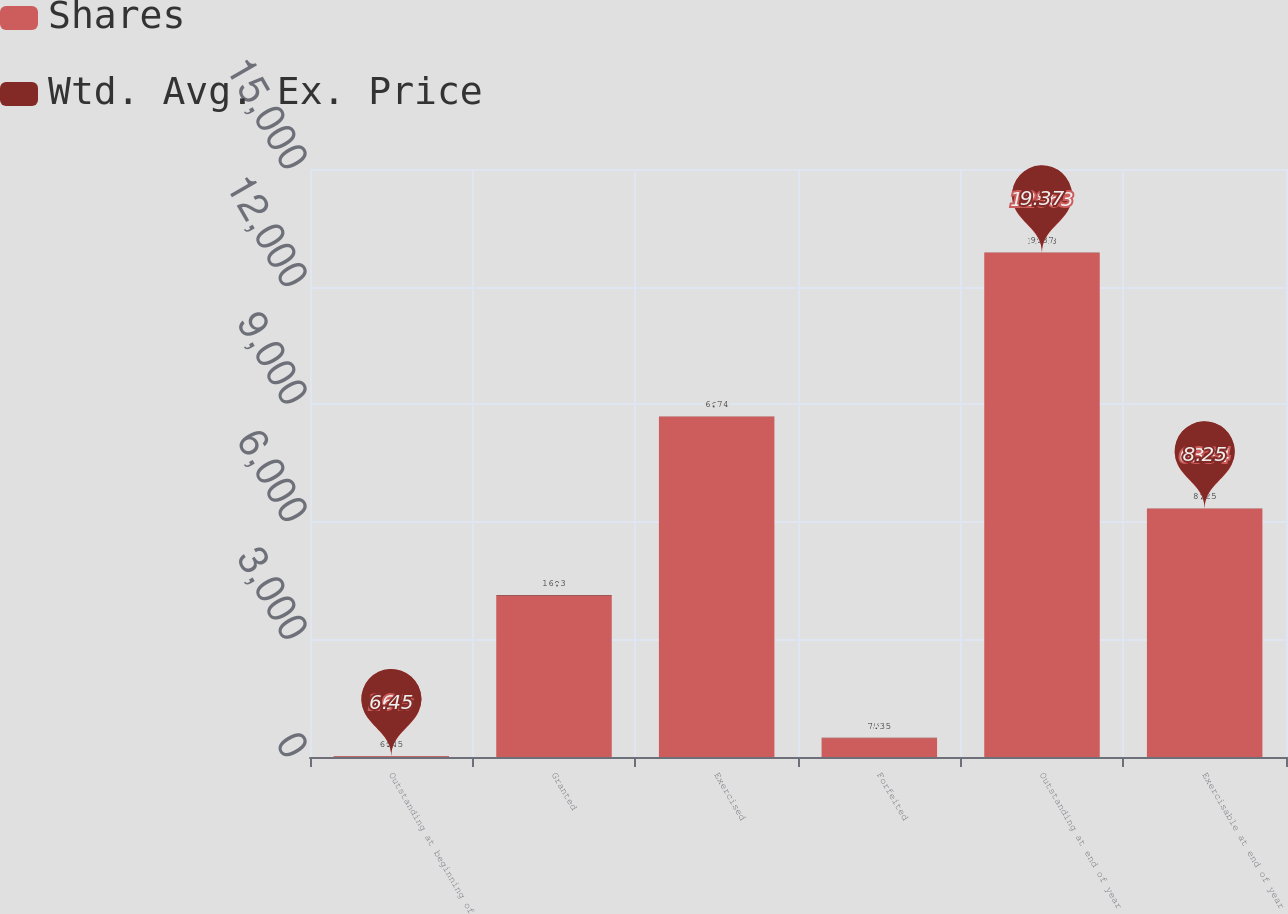Convert chart. <chart><loc_0><loc_0><loc_500><loc_500><stacked_bar_chart><ecel><fcel>Outstanding at beginning of<fcel>Granted<fcel>Exercised<fcel>Forfeited<fcel>Outstanding at end of year<fcel>Exercisable at end of year<nl><fcel>Shares<fcel>16.3<fcel>4109<fcel>8681<fcel>481<fcel>12863<fcel>6334<nl><fcel>Wtd. Avg. Ex. Price<fcel>6.45<fcel>16.3<fcel>6.74<fcel>7.35<fcel>9.37<fcel>8.25<nl></chart> 